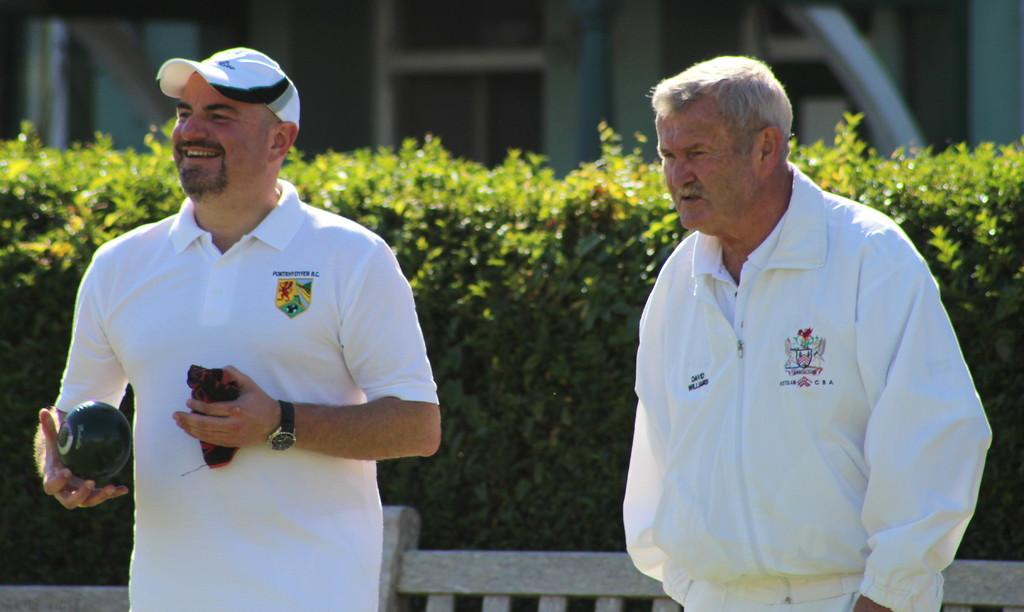How many people are in the image? There are two persons in the image. Where is the first person located? The first person is on the left side. What is the first person holding? The person on the left side is holding a ball. What color are the dresses worn by both persons? Both persons are wearing white color dress. What can be seen behind the persons? There are bushes behind the persons. What type of advice is the governor giving to the persons in the image? There is no governor present in the image, so no advice can be given. How many geese are visible in the image? There are no geese present in the image. 